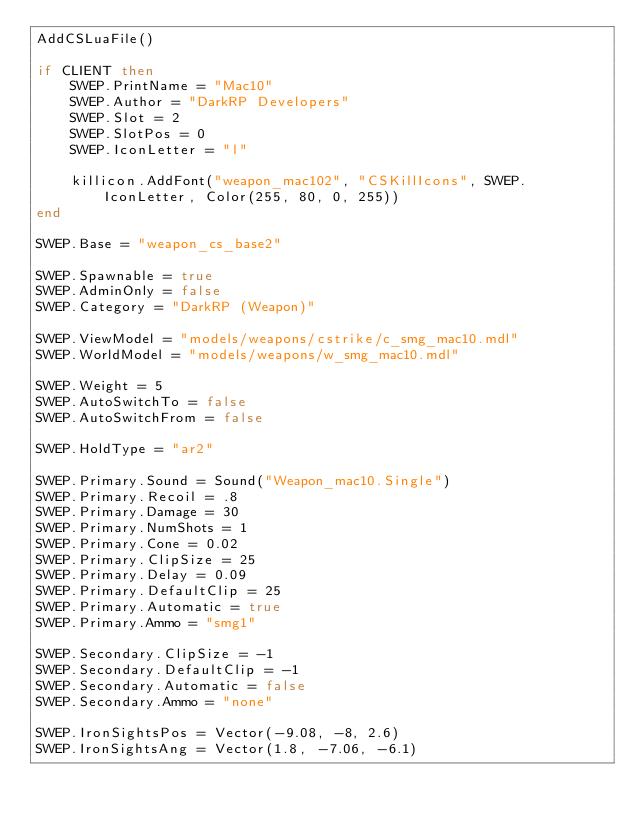Convert code to text. <code><loc_0><loc_0><loc_500><loc_500><_Lua_>AddCSLuaFile()

if CLIENT then
    SWEP.PrintName = "Mac10"
    SWEP.Author = "DarkRP Developers"
    SWEP.Slot = 2
    SWEP.SlotPos = 0
    SWEP.IconLetter = "l"

    killicon.AddFont("weapon_mac102", "CSKillIcons", SWEP.IconLetter, Color(255, 80, 0, 255))
end

SWEP.Base = "weapon_cs_base2"

SWEP.Spawnable = true
SWEP.AdminOnly = false
SWEP.Category = "DarkRP (Weapon)"

SWEP.ViewModel = "models/weapons/cstrike/c_smg_mac10.mdl"
SWEP.WorldModel = "models/weapons/w_smg_mac10.mdl"

SWEP.Weight = 5
SWEP.AutoSwitchTo = false
SWEP.AutoSwitchFrom = false

SWEP.HoldType = "ar2"

SWEP.Primary.Sound = Sound("Weapon_mac10.Single")
SWEP.Primary.Recoil = .8
SWEP.Primary.Damage = 30
SWEP.Primary.NumShots = 1
SWEP.Primary.Cone = 0.02
SWEP.Primary.ClipSize = 25
SWEP.Primary.Delay = 0.09
SWEP.Primary.DefaultClip = 25
SWEP.Primary.Automatic = true
SWEP.Primary.Ammo = "smg1"

SWEP.Secondary.ClipSize = -1
SWEP.Secondary.DefaultClip = -1
SWEP.Secondary.Automatic = false
SWEP.Secondary.Ammo = "none"

SWEP.IronSightsPos = Vector(-9.08, -8, 2.6)
SWEP.IronSightsAng = Vector(1.8, -7.06, -6.1)
</code> 